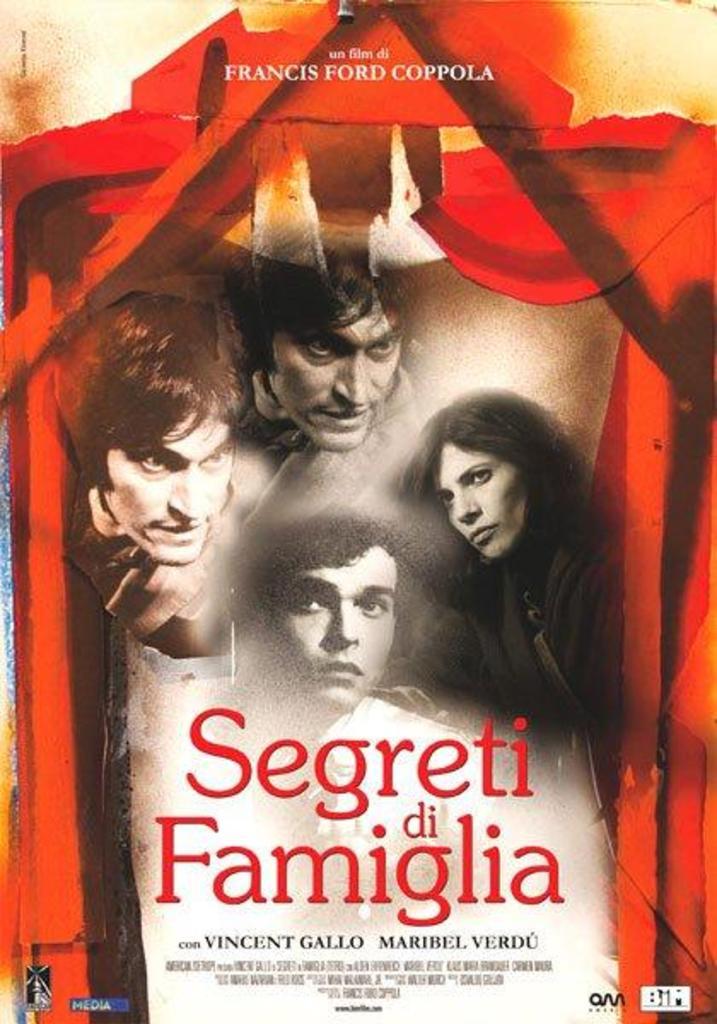What is the title of this show?
Provide a succinct answer. Segreti di famiglia. What is the first actors name listed?
Your response must be concise. Vincent gallo. 